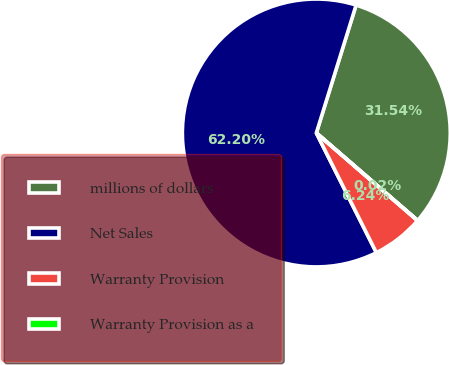Convert chart to OTSL. <chart><loc_0><loc_0><loc_500><loc_500><pie_chart><fcel>millions of dollars<fcel>Net Sales<fcel>Warranty Provision<fcel>Warranty Provision as a<nl><fcel>31.54%<fcel>62.2%<fcel>6.24%<fcel>0.02%<nl></chart> 